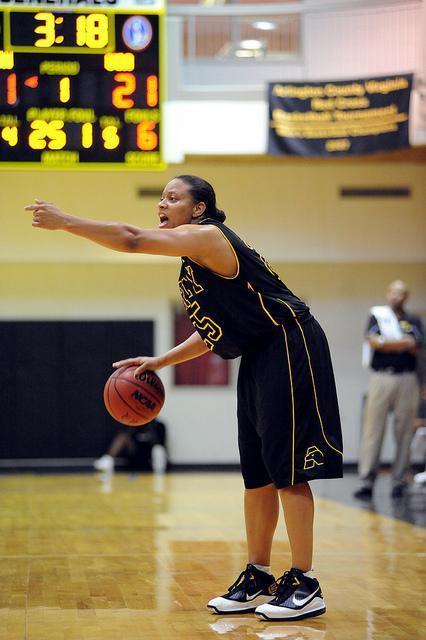How many people are visible?
Give a very brief answer. 3. 